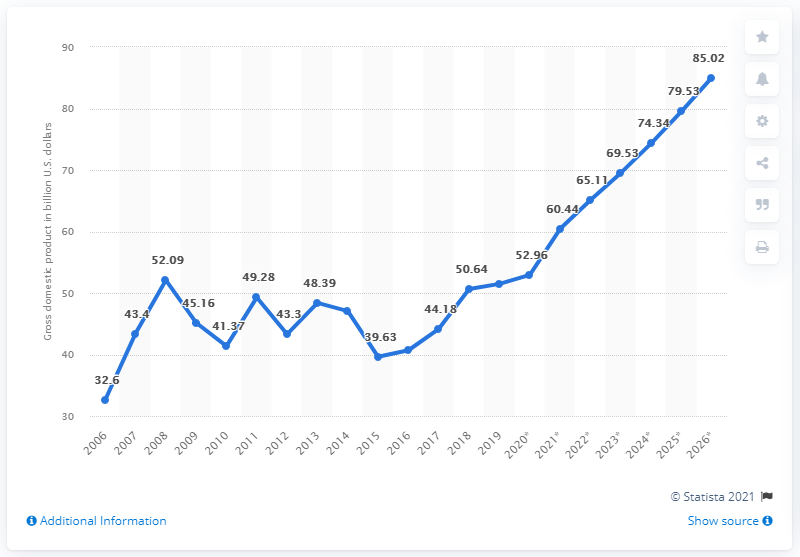Give some essential details in this illustration. In 2019, the gross domestic product of Serbia was $51.48 billion in U.S. dollars. 